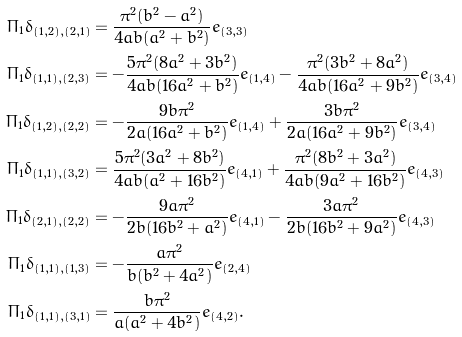<formula> <loc_0><loc_0><loc_500><loc_500>\Pi _ { 1 } \delta _ { ( 1 , 2 ) , ( 2 , 1 ) } & = \frac { \pi ^ { 2 } ( b ^ { 2 } - a ^ { 2 } ) } { 4 a b ( a ^ { 2 } + b ^ { 2 } ) } e _ { ( 3 , 3 ) } \\ \Pi _ { 1 } \delta _ { ( 1 , 1 ) , ( 2 , 3 ) } & = - \frac { 5 \pi ^ { 2 } ( 8 a ^ { 2 } + 3 b ^ { 2 } ) } { 4 a b ( 1 6 a ^ { 2 } + b ^ { 2 } ) } e _ { ( 1 , 4 ) } - \frac { \pi ^ { 2 } ( 3 b ^ { 2 } + 8 a ^ { 2 } ) } { 4 a b ( 1 6 a ^ { 2 } + 9 b ^ { 2 } ) } e _ { ( 3 , 4 ) } \\ \Pi _ { 1 } \delta _ { ( 1 , 2 ) , ( 2 , 2 ) } & = - \frac { 9 b \pi ^ { 2 } } { 2 a ( 1 6 a ^ { 2 } + b ^ { 2 } ) } e _ { ( 1 , 4 ) } + \frac { 3 b \pi ^ { 2 } } { 2 a ( 1 6 a ^ { 2 } + 9 b ^ { 2 } ) } e _ { ( 3 , 4 ) } \\ \Pi _ { 1 } \delta _ { ( 1 , 1 ) , ( 3 , 2 ) } & = \frac { 5 \pi ^ { 2 } ( 3 a ^ { 2 } + 8 b ^ { 2 } ) } { 4 a b ( a ^ { 2 } + 1 6 b ^ { 2 } ) } e _ { ( 4 , 1 ) } + \frac { \pi ^ { 2 } ( 8 b ^ { 2 } + 3 a ^ { 2 } ) } { 4 a b ( 9 a ^ { 2 } + 1 6 b ^ { 2 } ) } e _ { ( 4 , 3 ) } \\ \Pi _ { 1 } \delta _ { ( 2 , 1 ) , ( 2 , 2 ) } & = - \frac { 9 a \pi ^ { 2 } } { 2 b ( 1 6 b ^ { 2 } + a ^ { 2 } ) } e _ { ( 4 , 1 ) } - \frac { 3 a \pi ^ { 2 } } { 2 b ( 1 6 b ^ { 2 } + 9 a ^ { 2 } ) } e _ { ( 4 , 3 ) } \\ \Pi _ { 1 } \delta _ { ( 1 , 1 ) , ( 1 , 3 ) } & = - \frac { a \pi ^ { 2 } } { b ( b ^ { 2 } + 4 a ^ { 2 } ) } e _ { ( 2 , 4 ) } \\ \Pi _ { 1 } \delta _ { ( 1 , 1 ) , ( 3 , 1 ) } & = \frac { b \pi ^ { 2 } } { a ( a ^ { 2 } + 4 b ^ { 2 } ) } e _ { ( 4 , 2 ) } .</formula> 